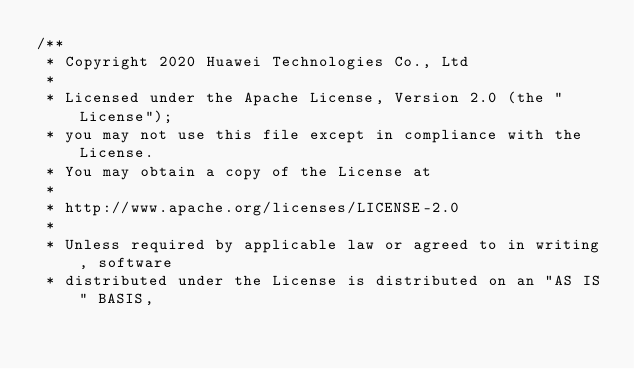<code> <loc_0><loc_0><loc_500><loc_500><_Cuda_>/**
 * Copyright 2020 Huawei Technologies Co., Ltd
 *
 * Licensed under the Apache License, Version 2.0 (the "License");
 * you may not use this file except in compliance with the License.
 * You may obtain a copy of the License at
 *
 * http://www.apache.org/licenses/LICENSE-2.0
 *
 * Unless required by applicable law or agreed to in writing, software
 * distributed under the License is distributed on an "AS IS" BASIS,</code> 